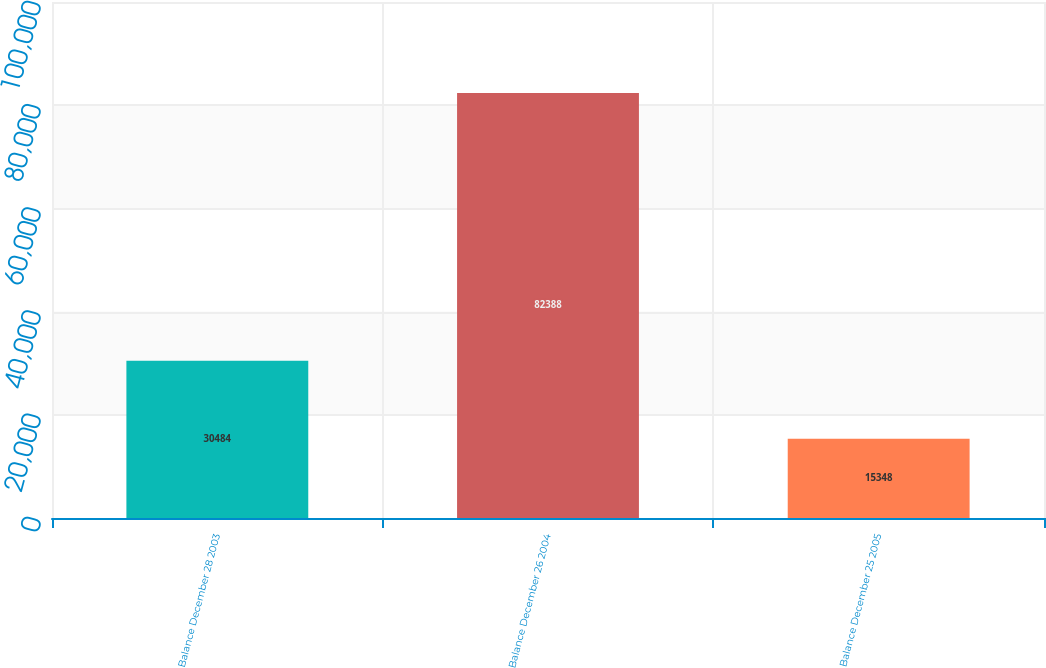<chart> <loc_0><loc_0><loc_500><loc_500><bar_chart><fcel>Balance December 28 2003<fcel>Balance December 26 2004<fcel>Balance December 25 2005<nl><fcel>30484<fcel>82388<fcel>15348<nl></chart> 